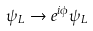<formula> <loc_0><loc_0><loc_500><loc_500>\psi _ { L } \rightarrow e ^ { i \phi } \psi _ { L }</formula> 